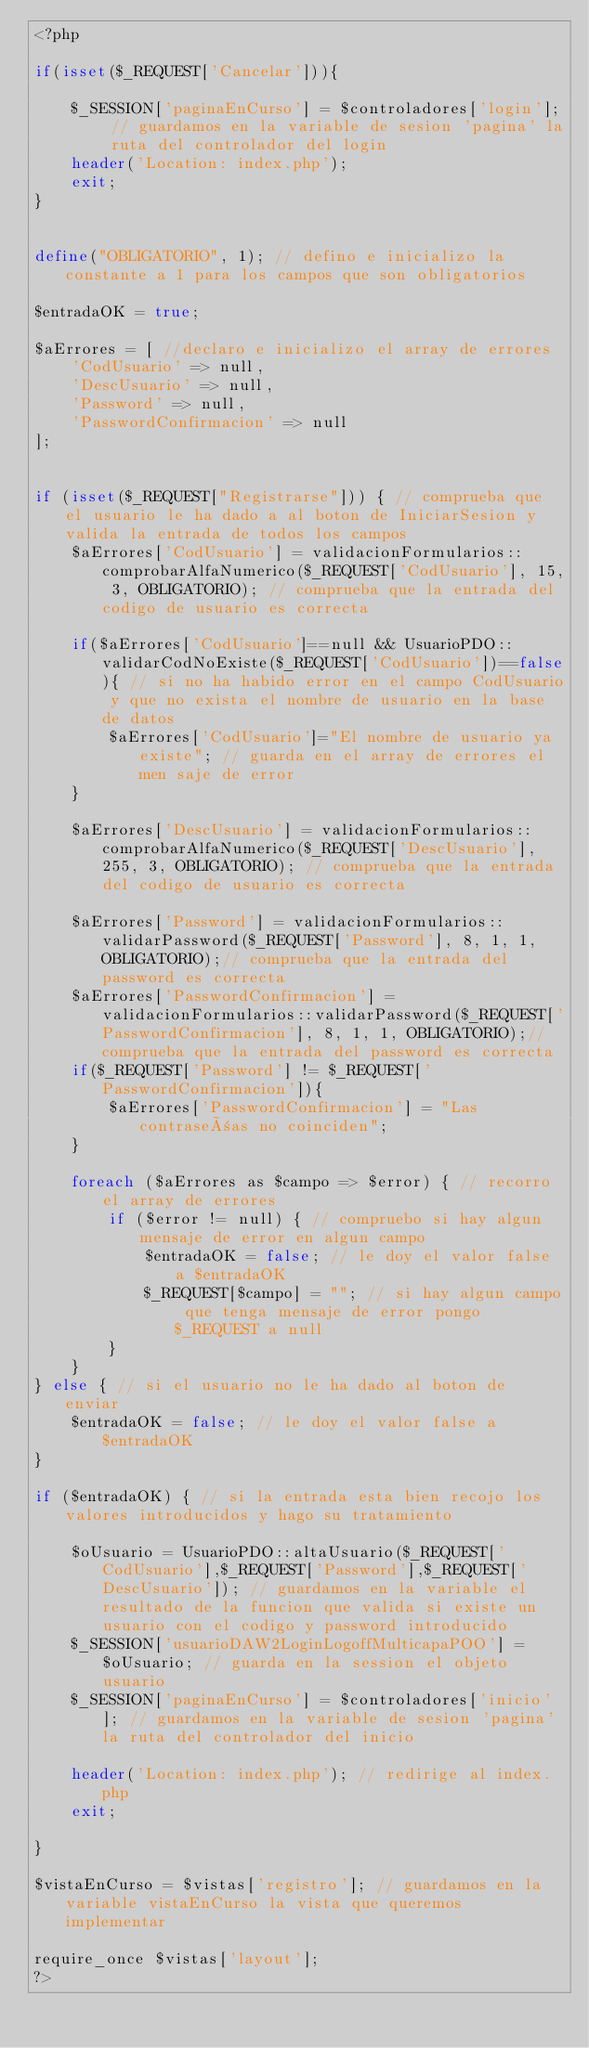Convert code to text. <code><loc_0><loc_0><loc_500><loc_500><_PHP_><?php

if(isset($_REQUEST['Cancelar'])){
    
    $_SESSION['paginaEnCurso'] = $controladores['login']; // guardamos en la variable de sesion 'pagina' la ruta del controlador del login
    header('Location: index.php');
    exit;
}


define("OBLIGATORIO", 1); // defino e inicializo la constante a 1 para los campos que son obligatorios

$entradaOK = true;

$aErrores = [ //declaro e inicializo el array de errores
    'CodUsuario' => null,
    'DescUsuario' => null,
    'Password' => null,
    'PasswordConfirmacion' => null
];


if (isset($_REQUEST["Registrarse"])) { // comprueba que el usuario le ha dado a al boton de IniciarSesion y valida la entrada de todos los campos
    $aErrores['CodUsuario'] = validacionFormularios::comprobarAlfaNumerico($_REQUEST['CodUsuario'], 15, 3, OBLIGATORIO); // comprueba que la entrada del codigo de usuario es correcta

    if($aErrores['CodUsuario']==null && UsuarioPDO::validarCodNoExiste($_REQUEST['CodUsuario'])==false){ // si no ha habido error en el campo CodUsuario y que no exista el nombre de usuario en la base de datos
        $aErrores['CodUsuario']="El nombre de usuario ya existe"; // guarda en el array de errores el men saje de error
    }

    $aErrores['DescUsuario'] = validacionFormularios::comprobarAlfaNumerico($_REQUEST['DescUsuario'], 255, 3, OBLIGATORIO); // comprueba que la entrada del codigo de usuario es correcta
    
    $aErrores['Password'] = validacionFormularios::validarPassword($_REQUEST['Password'], 8, 1, 1, OBLIGATORIO);// comprueba que la entrada del password es correcta
    $aErrores['PasswordConfirmacion'] = validacionFormularios::validarPassword($_REQUEST['PasswordConfirmacion'], 8, 1, 1, OBLIGATORIO);// comprueba que la entrada del password es correcta
    if($_REQUEST['Password'] != $_REQUEST['PasswordConfirmacion']){
        $aErrores['PasswordConfirmacion'] = "Las contraseñas no coinciden";
    }
    
    foreach ($aErrores as $campo => $error) { // recorro el array de errores
        if ($error != null) { // compruebo si hay algun mensaje de error en algun campo
            $entradaOK = false; // le doy el valor false a $entradaOK
            $_REQUEST[$campo] = ""; // si hay algun campo que tenga mensaje de error pongo $_REQUEST a null
        }
    }
} else { // si el usuario no le ha dado al boton de enviar
    $entradaOK = false; // le doy el valor false a $entradaOK
}

if ($entradaOK) { // si la entrada esta bien recojo los valores introducidos y hago su tratamiento

    $oUsuario = UsuarioPDO::altaUsuario($_REQUEST['CodUsuario'],$_REQUEST['Password'],$_REQUEST['DescUsuario']); // guardamos en la variable el resultado de la funcion que valida si existe un usuario con el codigo y password introducido
    $_SESSION['usuarioDAW2LoginLogoffMulticapaPOO'] = $oUsuario; // guarda en la session el objeto usuario
    $_SESSION['paginaEnCurso'] = $controladores['inicio']; // guardamos en la variable de sesion 'pagina' la ruta del controlador del inicio

    header('Location: index.php'); // redirige al index.php
    exit;

}

$vistaEnCurso = $vistas['registro']; // guardamos en la variable vistaEnCurso la vista que queremos implementar

require_once $vistas['layout'];
?> </code> 